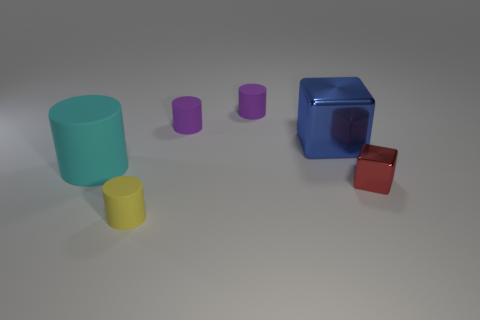Add 3 large blocks. How many objects exist? 9 Subtract all cylinders. How many objects are left? 2 Subtract 0 green balls. How many objects are left? 6 Subtract all big cyan matte cylinders. Subtract all cyan matte objects. How many objects are left? 4 Add 2 big blue metallic cubes. How many big blue metallic cubes are left? 3 Add 6 purple rubber cylinders. How many purple rubber cylinders exist? 8 